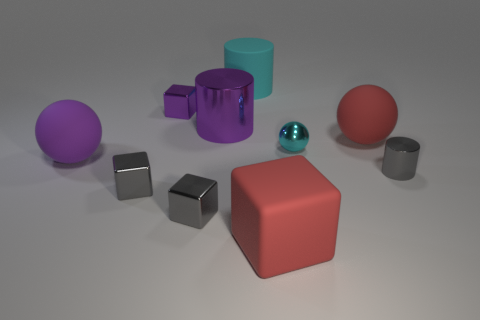There is a cylinder right of the cyan rubber object; is it the same size as the cyan metal ball?
Offer a very short reply. Yes. What is the material of the large cube?
Offer a terse response. Rubber. There is a small metallic cube behind the large purple cylinder; what is its color?
Ensure brevity in your answer.  Purple. What number of large things are brown metallic cylinders or cyan metallic balls?
Make the answer very short. 0. There is a big matte ball that is in front of the small cyan sphere; is it the same color as the rubber thing in front of the gray metal cylinder?
Your response must be concise. No. What number of other objects are there of the same color as the big shiny cylinder?
Make the answer very short. 2. What number of cyan things are large shiny things or small cubes?
Keep it short and to the point. 0. There is a tiny purple metal thing; is its shape the same as the large red thing that is behind the big purple rubber ball?
Your answer should be very brief. No. There is a large purple matte thing; what shape is it?
Provide a short and direct response. Sphere. There is a cylinder that is the same size as the cyan ball; what is it made of?
Offer a terse response. Metal. 